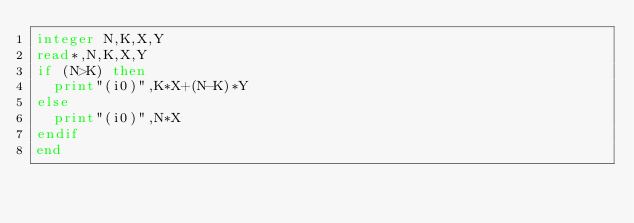Convert code to text. <code><loc_0><loc_0><loc_500><loc_500><_FORTRAN_>integer N,K,X,Y
read*,N,K,X,Y
if (N>K) then
	print"(i0)",K*X+(N-K)*Y
else
	print"(i0)",N*X
endif
end</code> 